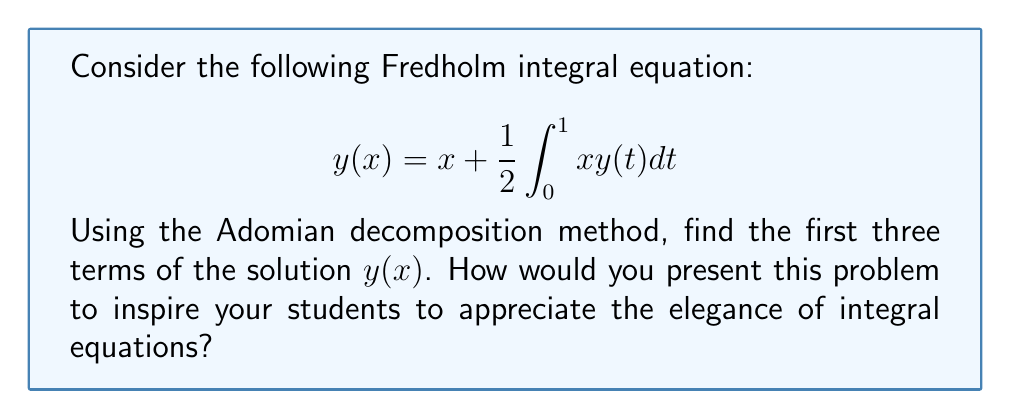Show me your answer to this math problem. Let's approach this step-by-step using the Adomian decomposition method:

1) First, we express the solution as an infinite series:
   $$y(x) = \sum_{n=0}^{\infty} y_n(x)$$

2) We then decompose the equation:
   $$\sum_{n=0}^{\infty} y_n(x) = x + \frac{1}{2}\int_0^1 x\sum_{n=0}^{\infty} y_n(t)dt$$

3) Now, we identify the terms:
   $$y_0(x) = x$$
   $$y_n(x) = \frac{1}{2}\int_0^1 xy_{n-1}(t)dt, \quad n \geq 1$$

4) Let's calculate the first three terms:

   For $y_1(x)$:
   $$y_1(x) = \frac{1}{2}\int_0^1 xy_0(t)dt = \frac{1}{2}\int_0^1 xtdt = \frac{x}{4}$$

   For $y_2(x)$:
   $$y_2(x) = \frac{1}{2}\int_0^1 xy_1(t)dt = \frac{1}{2}\int_0^1 x\cdot\frac{t}{4}dt = \frac{x}{32}$$

   For $y_3(x)$:
   $$y_3(x) = \frac{1}{2}\int_0^1 xy_2(t)dt = \frac{1}{2}\int_0^1 x\cdot\frac{t}{32}dt = \frac{x}{256}$$

5) Therefore, the first three terms of the solution are:
   $$y(x) \approx y_0(x) + y_1(x) + y_2(x) = x + \frac{x}{4} + \frac{x}{32}$$

To inspire students, we can highlight how this method allows us to approach complex integral equations systematically, breaking them down into more manageable pieces. We can also discuss how each term contributes to the overall solution, demonstrating the power of series representations in mathematics.
Answer: $y(x) \approx x + \frac{x}{4} + \frac{x}{32}$ 